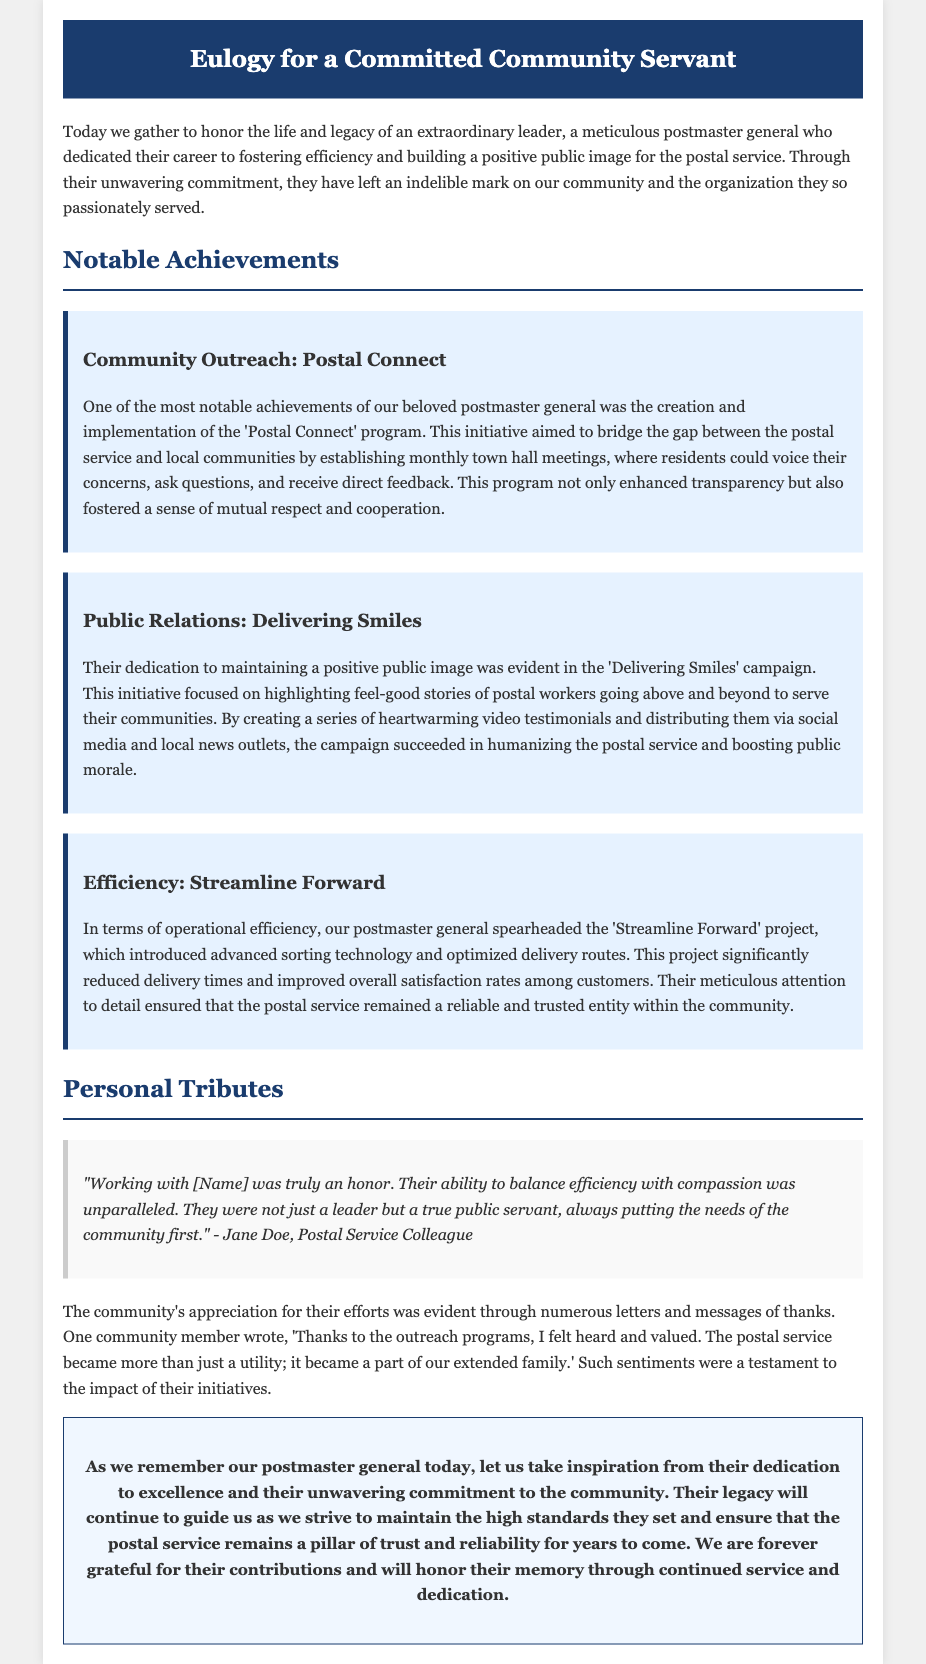what was the title of the document? The title is found in the header of the document, 'Eulogy for a Committed Community Servant.'
Answer: Eulogy for a Committed Community Servant who created the 'Postal Connect' program? The document states that it was created and implemented by the postmaster general being honored in the eulogy.
Answer: postmaster general what initiative was focused on public relations? The document mentions the 'Delivering Smiles' campaign as the initiative aimed at improving public relations.
Answer: Delivering Smiles how many notable achievements are highlighted? The section on notable achievements mentions three specific initiatives, indicating the total number.
Answer: three what project improved operational efficiency? The project mentioned that enhanced efficiency is referred to as 'Streamline Forward.'
Answer: Streamline Forward who expressed admiration for the postmaster general's balance of efficiency and compassion? The quote credits admiration to Jane Doe, who is identified as a Postal Service Colleague.
Answer: Jane Doe which program allowed community members to voice concerns? The document specifies that 'Postal Connect' was the program designed for this purpose.
Answer: Postal Connect what type of stories did the 'Delivering Smiles' campaign highlight? The campaign focused on feel-good stories involving postal workers serving their communities.
Answer: feel-good stories what sentiment did a community member express about outreach programs? The community member expressed feeling heard and valued due to the outreach programs.
Answer: felt heard and valued 